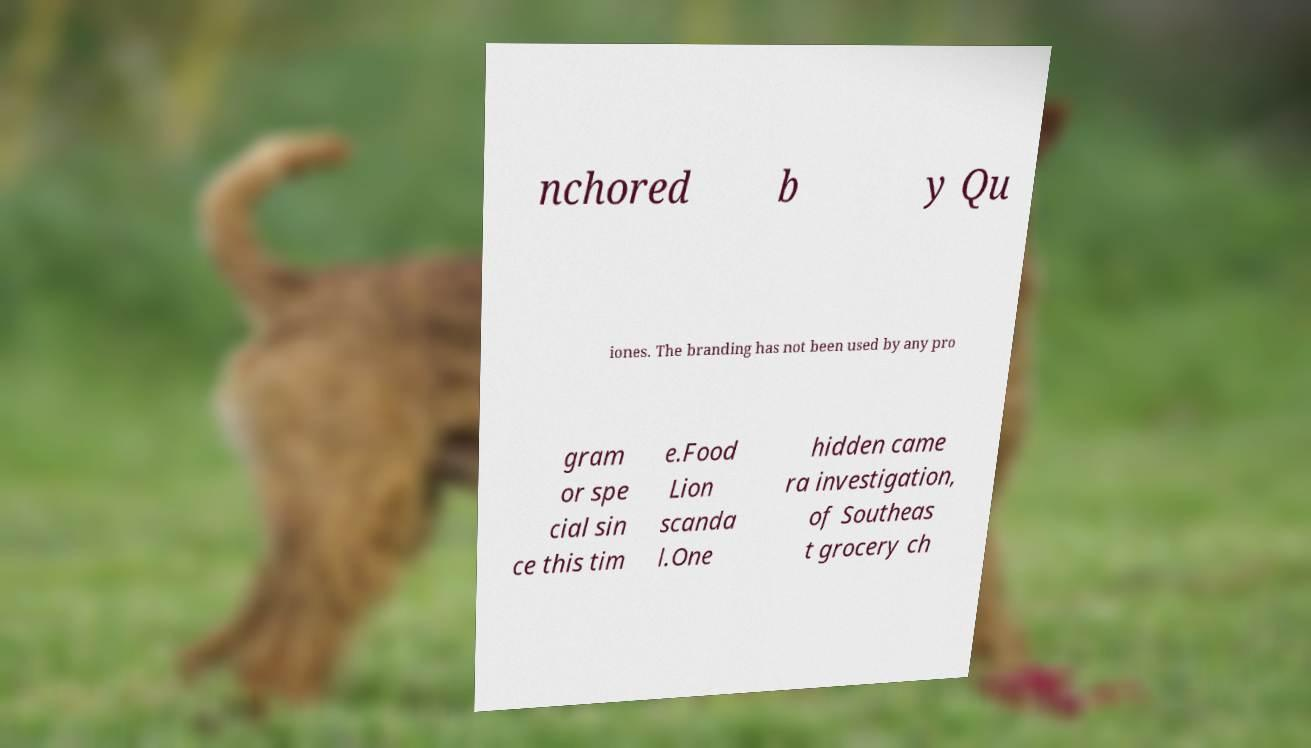What messages or text are displayed in this image? I need them in a readable, typed format. nchored b y Qu iones. The branding has not been used by any pro gram or spe cial sin ce this tim e.Food Lion scanda l.One hidden came ra investigation, of Southeas t grocery ch 